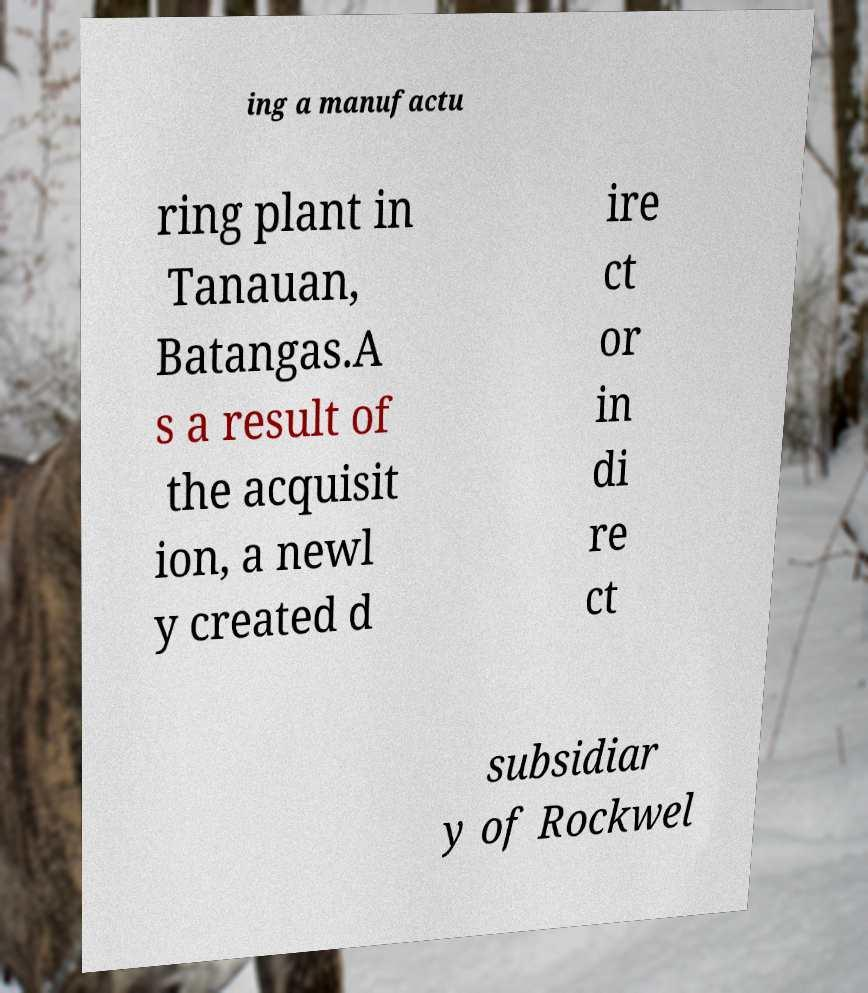What messages or text are displayed in this image? I need them in a readable, typed format. ing a manufactu ring plant in Tanauan, Batangas.A s a result of the acquisit ion, a newl y created d ire ct or in di re ct subsidiar y of Rockwel 